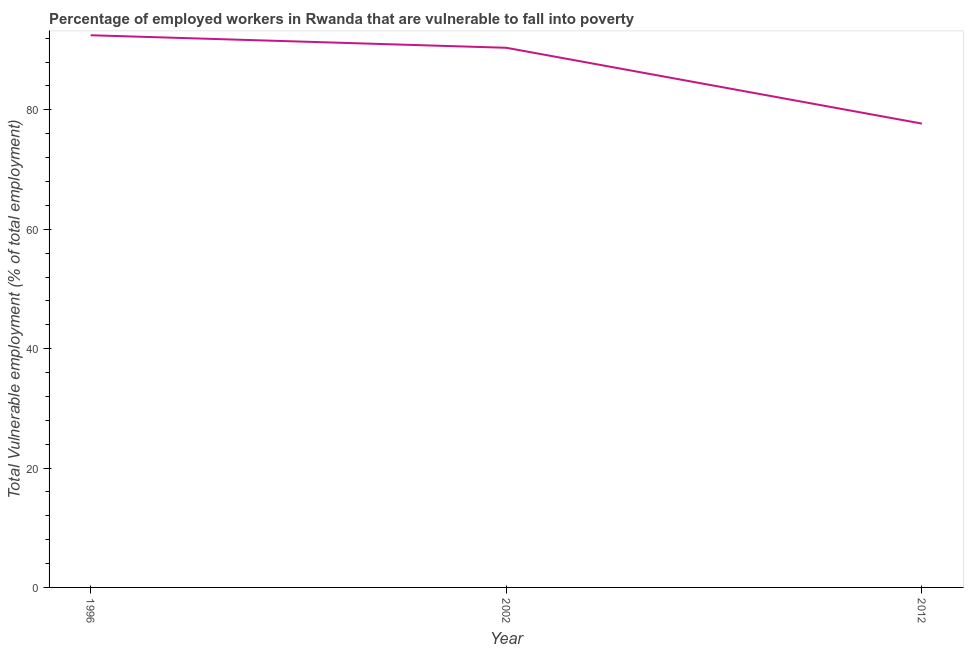What is the total vulnerable employment in 2002?
Ensure brevity in your answer.  90.4. Across all years, what is the maximum total vulnerable employment?
Your answer should be very brief. 92.5. Across all years, what is the minimum total vulnerable employment?
Your response must be concise. 77.7. In which year was the total vulnerable employment minimum?
Give a very brief answer. 2012. What is the sum of the total vulnerable employment?
Offer a very short reply. 260.6. What is the difference between the total vulnerable employment in 1996 and 2012?
Your response must be concise. 14.8. What is the average total vulnerable employment per year?
Keep it short and to the point. 86.87. What is the median total vulnerable employment?
Keep it short and to the point. 90.4. Do a majority of the years between 1996 and 2002 (inclusive) have total vulnerable employment greater than 44 %?
Ensure brevity in your answer.  Yes. What is the ratio of the total vulnerable employment in 2002 to that in 2012?
Your answer should be very brief. 1.16. Is the difference between the total vulnerable employment in 1996 and 2012 greater than the difference between any two years?
Your response must be concise. Yes. What is the difference between the highest and the second highest total vulnerable employment?
Provide a short and direct response. 2.1. What is the difference between the highest and the lowest total vulnerable employment?
Your answer should be very brief. 14.8. In how many years, is the total vulnerable employment greater than the average total vulnerable employment taken over all years?
Make the answer very short. 2. Does the total vulnerable employment monotonically increase over the years?
Give a very brief answer. No. How many years are there in the graph?
Offer a very short reply. 3. Are the values on the major ticks of Y-axis written in scientific E-notation?
Ensure brevity in your answer.  No. Does the graph contain any zero values?
Offer a terse response. No. Does the graph contain grids?
Ensure brevity in your answer.  No. What is the title of the graph?
Your answer should be very brief. Percentage of employed workers in Rwanda that are vulnerable to fall into poverty. What is the label or title of the Y-axis?
Your answer should be very brief. Total Vulnerable employment (% of total employment). What is the Total Vulnerable employment (% of total employment) of 1996?
Your answer should be compact. 92.5. What is the Total Vulnerable employment (% of total employment) in 2002?
Your answer should be compact. 90.4. What is the Total Vulnerable employment (% of total employment) in 2012?
Keep it short and to the point. 77.7. What is the difference between the Total Vulnerable employment (% of total employment) in 1996 and 2002?
Provide a succinct answer. 2.1. What is the difference between the Total Vulnerable employment (% of total employment) in 2002 and 2012?
Your answer should be compact. 12.7. What is the ratio of the Total Vulnerable employment (% of total employment) in 1996 to that in 2012?
Give a very brief answer. 1.19. What is the ratio of the Total Vulnerable employment (% of total employment) in 2002 to that in 2012?
Provide a short and direct response. 1.16. 